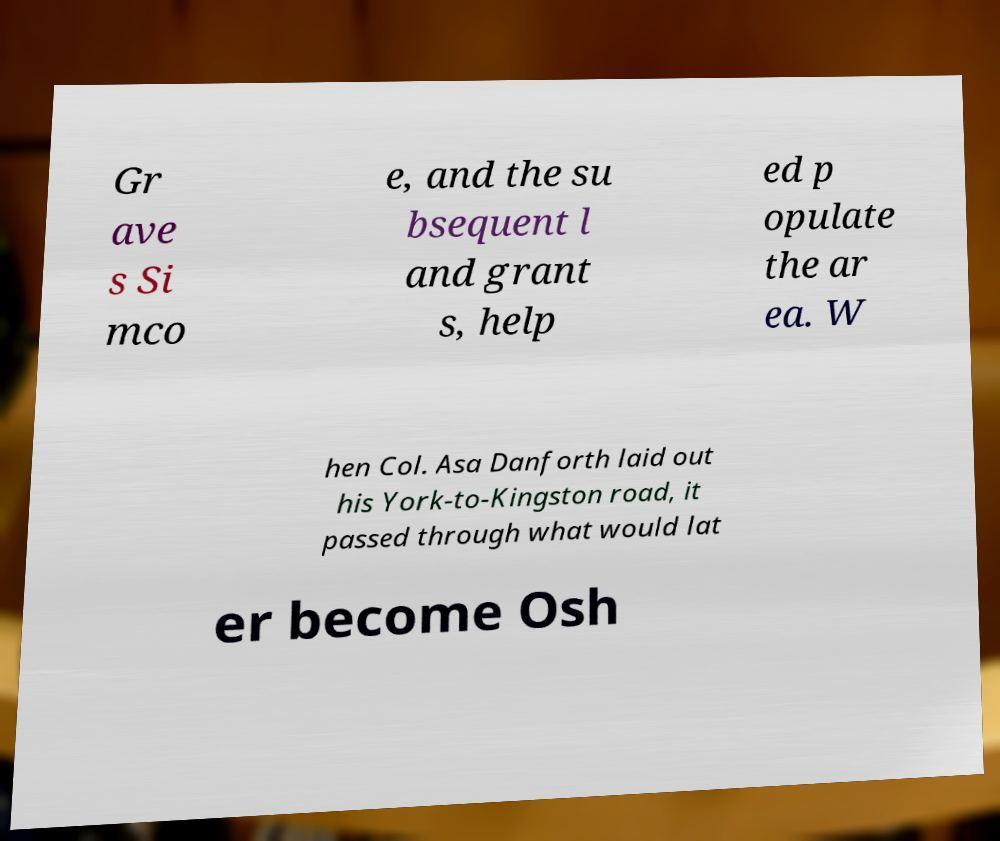For documentation purposes, I need the text within this image transcribed. Could you provide that? Gr ave s Si mco e, and the su bsequent l and grant s, help ed p opulate the ar ea. W hen Col. Asa Danforth laid out his York-to-Kingston road, it passed through what would lat er become Osh 